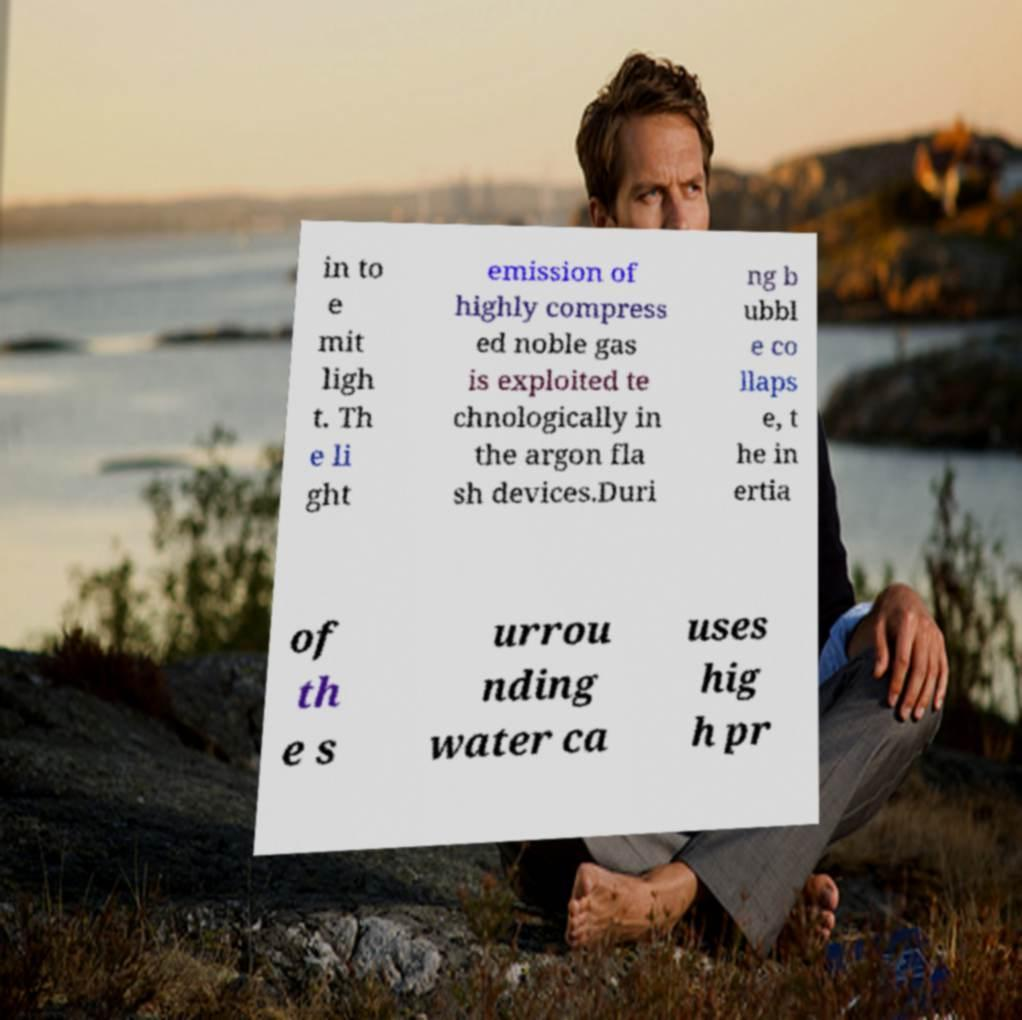Could you assist in decoding the text presented in this image and type it out clearly? in to e mit ligh t. Th e li ght emission of highly compress ed noble gas is exploited te chnologically in the argon fla sh devices.Duri ng b ubbl e co llaps e, t he in ertia of th e s urrou nding water ca uses hig h pr 